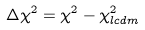Convert formula to latex. <formula><loc_0><loc_0><loc_500><loc_500>\Delta \chi ^ { 2 } = \chi ^ { 2 } - \chi ^ { 2 } _ { l c d m }</formula> 